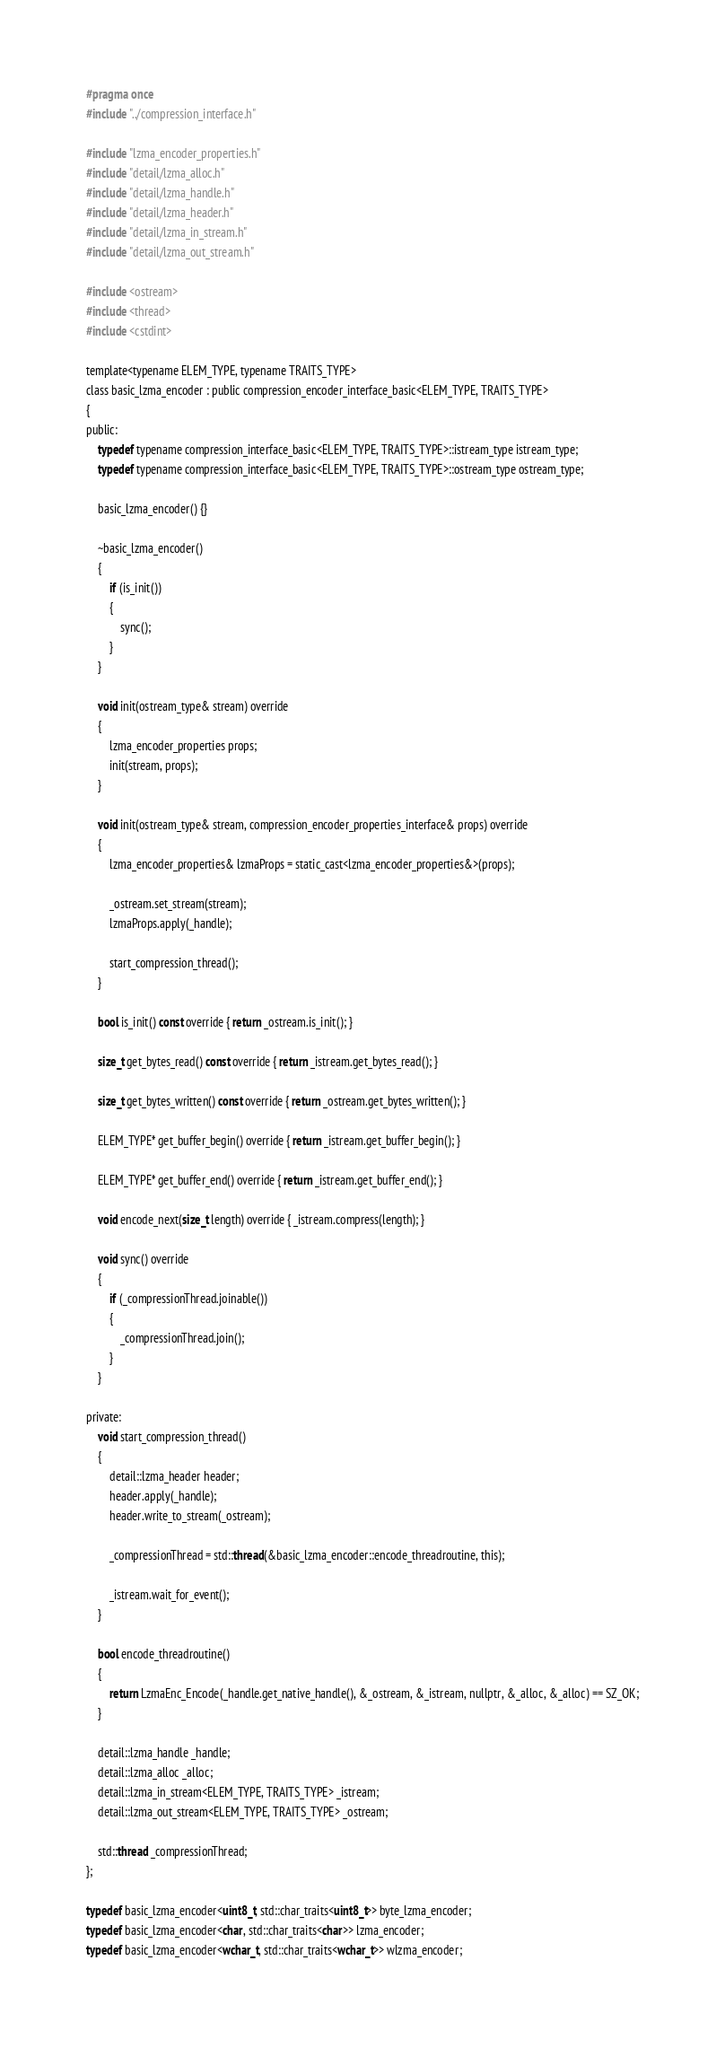Convert code to text. <code><loc_0><loc_0><loc_500><loc_500><_C_>#pragma once
#include "../compression_interface.h"

#include "lzma_encoder_properties.h"
#include "detail/lzma_alloc.h"
#include "detail/lzma_handle.h"
#include "detail/lzma_header.h"
#include "detail/lzma_in_stream.h"
#include "detail/lzma_out_stream.h"

#include <ostream>
#include <thread>
#include <cstdint>

template<typename ELEM_TYPE, typename TRAITS_TYPE>
class basic_lzma_encoder : public compression_encoder_interface_basic<ELEM_TYPE, TRAITS_TYPE>
{
public:
    typedef typename compression_interface_basic<ELEM_TYPE, TRAITS_TYPE>::istream_type istream_type;
    typedef typename compression_interface_basic<ELEM_TYPE, TRAITS_TYPE>::ostream_type ostream_type;

    basic_lzma_encoder() {}

    ~basic_lzma_encoder()
    {
        if (is_init())
        {
            sync();
        }
    }

    void init(ostream_type& stream) override
    {
        lzma_encoder_properties props;
        init(stream, props);
    }

    void init(ostream_type& stream, compression_encoder_properties_interface& props) override
    {
        lzma_encoder_properties& lzmaProps = static_cast<lzma_encoder_properties&>(props);

        _ostream.set_stream(stream);
        lzmaProps.apply(_handle);

        start_compression_thread();
    }

    bool is_init() const override { return _ostream.is_init(); }

    size_t get_bytes_read() const override { return _istream.get_bytes_read(); }

    size_t get_bytes_written() const override { return _ostream.get_bytes_written(); }

    ELEM_TYPE* get_buffer_begin() override { return _istream.get_buffer_begin(); }

    ELEM_TYPE* get_buffer_end() override { return _istream.get_buffer_end(); }

    void encode_next(size_t length) override { _istream.compress(length); }

    void sync() override
    {
        if (_compressionThread.joinable())
        {
            _compressionThread.join();
        }
    }

private:
    void start_compression_thread()
    {
        detail::lzma_header header;
        header.apply(_handle);
        header.write_to_stream(_ostream);

        _compressionThread = std::thread(&basic_lzma_encoder::encode_threadroutine, this);

        _istream.wait_for_event();
    }

    bool encode_threadroutine()
    {
        return LzmaEnc_Encode(_handle.get_native_handle(), &_ostream, &_istream, nullptr, &_alloc, &_alloc) == SZ_OK;
    }

    detail::lzma_handle _handle;
    detail::lzma_alloc _alloc;
    detail::lzma_in_stream<ELEM_TYPE, TRAITS_TYPE> _istream;
    detail::lzma_out_stream<ELEM_TYPE, TRAITS_TYPE> _ostream;

    std::thread _compressionThread;
};

typedef basic_lzma_encoder<uint8_t, std::char_traits<uint8_t>> byte_lzma_encoder;
typedef basic_lzma_encoder<char, std::char_traits<char>> lzma_encoder;
typedef basic_lzma_encoder<wchar_t, std::char_traits<wchar_t>> wlzma_encoder;
</code> 